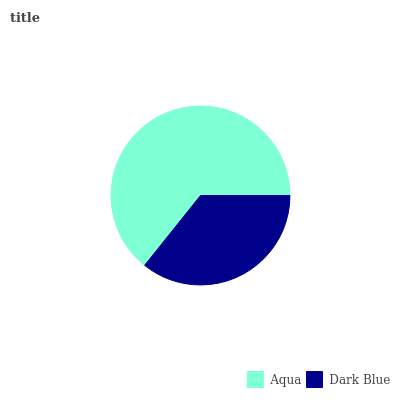Is Dark Blue the minimum?
Answer yes or no. Yes. Is Aqua the maximum?
Answer yes or no. Yes. Is Dark Blue the maximum?
Answer yes or no. No. Is Aqua greater than Dark Blue?
Answer yes or no. Yes. Is Dark Blue less than Aqua?
Answer yes or no. Yes. Is Dark Blue greater than Aqua?
Answer yes or no. No. Is Aqua less than Dark Blue?
Answer yes or no. No. Is Aqua the high median?
Answer yes or no. Yes. Is Dark Blue the low median?
Answer yes or no. Yes. Is Dark Blue the high median?
Answer yes or no. No. Is Aqua the low median?
Answer yes or no. No. 